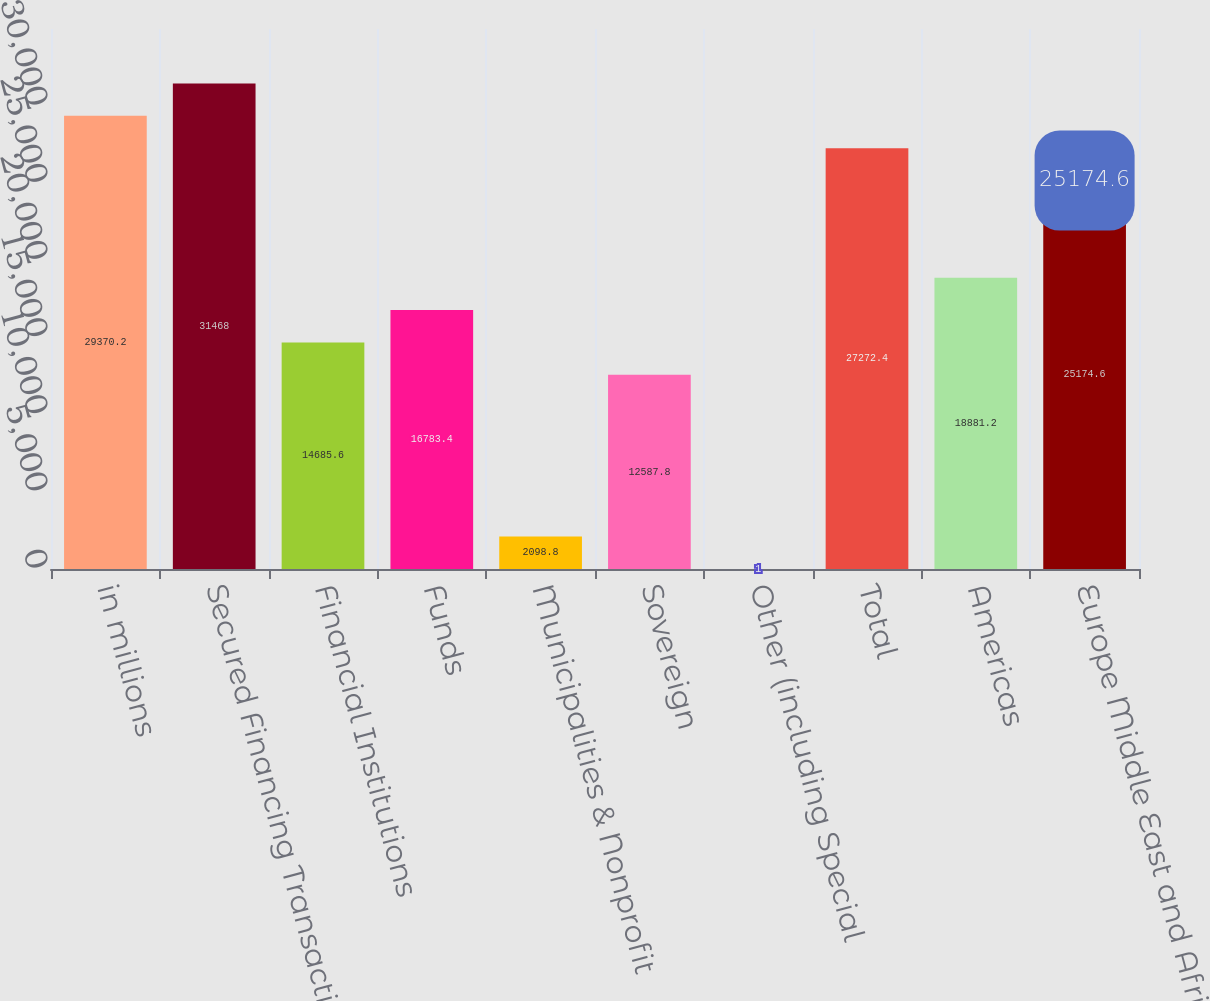Convert chart to OTSL. <chart><loc_0><loc_0><loc_500><loc_500><bar_chart><fcel>in millions<fcel>Secured Financing Transactions<fcel>Financial Institutions<fcel>Funds<fcel>Municipalities & Nonprofit<fcel>Sovereign<fcel>Other (including Special<fcel>Total<fcel>Americas<fcel>Europe Middle East and Africa<nl><fcel>29370.2<fcel>31468<fcel>14685.6<fcel>16783.4<fcel>2098.8<fcel>12587.8<fcel>1<fcel>27272.4<fcel>18881.2<fcel>25174.6<nl></chart> 